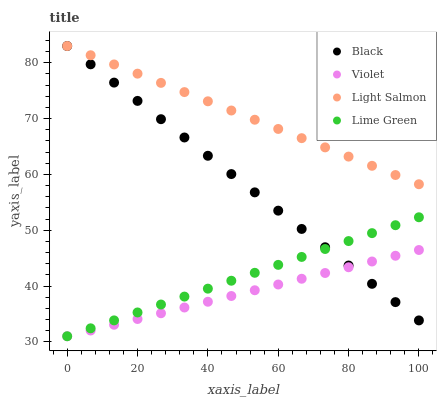Does Violet have the minimum area under the curve?
Answer yes or no. Yes. Does Light Salmon have the maximum area under the curve?
Answer yes or no. Yes. Does Black have the minimum area under the curve?
Answer yes or no. No. Does Black have the maximum area under the curve?
Answer yes or no. No. Is Black the smoothest?
Answer yes or no. Yes. Is Light Salmon the roughest?
Answer yes or no. Yes. Is Light Salmon the smoothest?
Answer yes or no. No. Is Black the roughest?
Answer yes or no. No. Does Lime Green have the lowest value?
Answer yes or no. Yes. Does Black have the lowest value?
Answer yes or no. No. Does Black have the highest value?
Answer yes or no. Yes. Does Violet have the highest value?
Answer yes or no. No. Is Lime Green less than Light Salmon?
Answer yes or no. Yes. Is Light Salmon greater than Lime Green?
Answer yes or no. Yes. Does Black intersect Lime Green?
Answer yes or no. Yes. Is Black less than Lime Green?
Answer yes or no. No. Is Black greater than Lime Green?
Answer yes or no. No. Does Lime Green intersect Light Salmon?
Answer yes or no. No. 